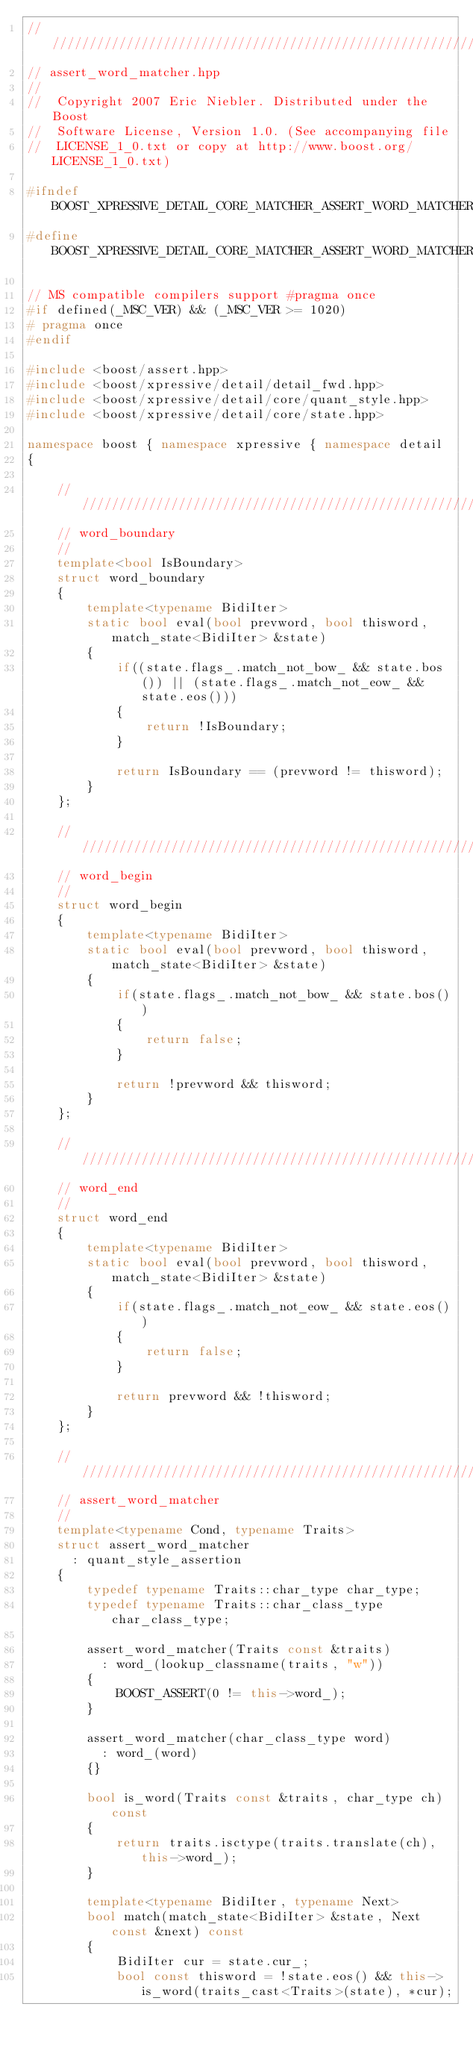<code> <loc_0><loc_0><loc_500><loc_500><_C++_>///////////////////////////////////////////////////////////////////////////////
// assert_word_matcher.hpp
//
//  Copyright 2007 Eric Niebler. Distributed under the Boost
//  Software License, Version 1.0. (See accompanying file
//  LICENSE_1_0.txt or copy at http://www.boost.org/LICENSE_1_0.txt)

#ifndef BOOST_XPRESSIVE_DETAIL_CORE_MATCHER_ASSERT_WORD_MATCHER_HPP_EAN_10_04_2005
#define BOOST_XPRESSIVE_DETAIL_CORE_MATCHER_ASSERT_WORD_MATCHER_HPP_EAN_10_04_2005

// MS compatible compilers support #pragma once
#if defined(_MSC_VER) && (_MSC_VER >= 1020)
# pragma once
#endif

#include <boost/assert.hpp>
#include <boost/xpressive/detail/detail_fwd.hpp>
#include <boost/xpressive/detail/core/quant_style.hpp>
#include <boost/xpressive/detail/core/state.hpp>

namespace boost { namespace xpressive { namespace detail
{

    ///////////////////////////////////////////////////////////////////////////////
    // word_boundary
    //
    template<bool IsBoundary>
    struct word_boundary
    {
        template<typename BidiIter>
        static bool eval(bool prevword, bool thisword, match_state<BidiIter> &state)
        {
            if((state.flags_.match_not_bow_ && state.bos()) || (state.flags_.match_not_eow_ && state.eos()))
            {
                return !IsBoundary;
            }

            return IsBoundary == (prevword != thisword);
        }
    };

    ///////////////////////////////////////////////////////////////////////////////
    // word_begin
    //
    struct word_begin
    {
        template<typename BidiIter>
        static bool eval(bool prevword, bool thisword, match_state<BidiIter> &state)
        {
            if(state.flags_.match_not_bow_ && state.bos())
            {
                return false;
            }

            return !prevword && thisword;
        }
    };

    ///////////////////////////////////////////////////////////////////////////////
    // word_end
    //
    struct word_end
    {
        template<typename BidiIter>
        static bool eval(bool prevword, bool thisword, match_state<BidiIter> &state)
        {
            if(state.flags_.match_not_eow_ && state.eos())
            {
                return false;
            }

            return prevword && !thisword;
        }
    };

    ///////////////////////////////////////////////////////////////////////////////
    // assert_word_matcher
    //
    template<typename Cond, typename Traits>
    struct assert_word_matcher
      : quant_style_assertion
    {
        typedef typename Traits::char_type char_type;
        typedef typename Traits::char_class_type char_class_type;

        assert_word_matcher(Traits const &traits)
          : word_(lookup_classname(traits, "w"))
        {
            BOOST_ASSERT(0 != this->word_);
        }

        assert_word_matcher(char_class_type word)
          : word_(word)
        {}

        bool is_word(Traits const &traits, char_type ch) const
        {
            return traits.isctype(traits.translate(ch), this->word_);
        }

        template<typename BidiIter, typename Next>
        bool match(match_state<BidiIter> &state, Next const &next) const
        {
            BidiIter cur = state.cur_;
            bool const thisword = !state.eos() && this->is_word(traits_cast<Traits>(state), *cur);</code> 